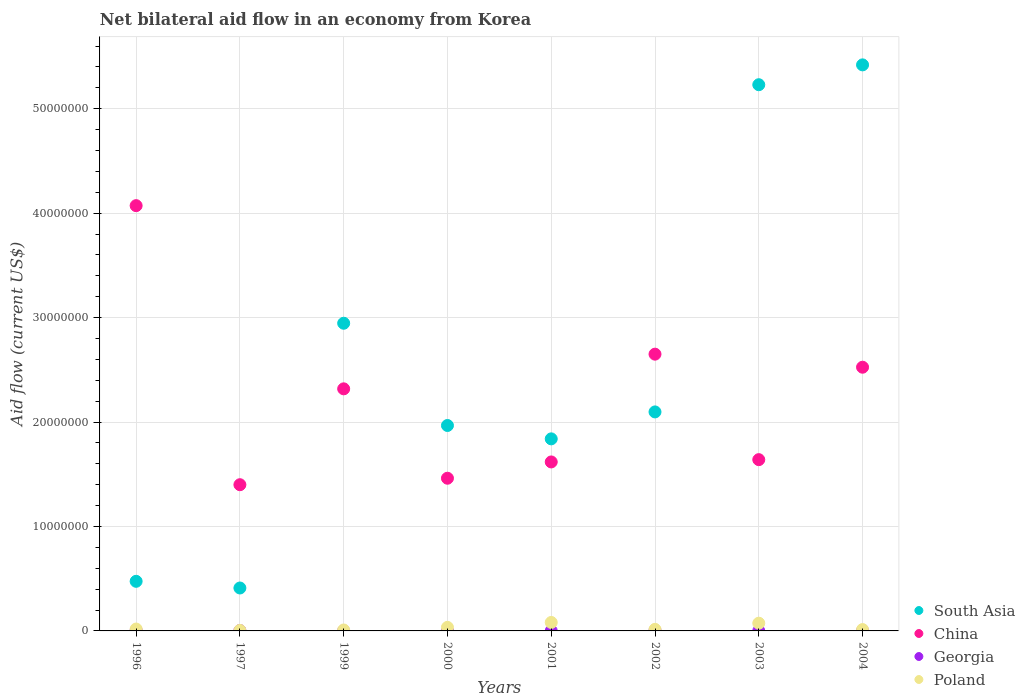Is the number of dotlines equal to the number of legend labels?
Provide a succinct answer. Yes. What is the net bilateral aid flow in China in 2004?
Your answer should be compact. 2.52e+07. Across all years, what is the maximum net bilateral aid flow in Poland?
Your answer should be very brief. 8.10e+05. Across all years, what is the minimum net bilateral aid flow in Georgia?
Keep it short and to the point. 10000. What is the total net bilateral aid flow in Georgia in the graph?
Offer a terse response. 2.30e+05. What is the difference between the net bilateral aid flow in Poland in 1997 and that in 2003?
Give a very brief answer. -6.90e+05. What is the difference between the net bilateral aid flow in Poland in 1999 and the net bilateral aid flow in South Asia in 1996?
Provide a short and direct response. -4.66e+06. What is the average net bilateral aid flow in South Asia per year?
Keep it short and to the point. 2.55e+07. In how many years, is the net bilateral aid flow in Georgia greater than 6000000 US$?
Your answer should be compact. 0. What is the ratio of the net bilateral aid flow in South Asia in 2001 to that in 2004?
Your answer should be very brief. 0.34. What is the difference between the highest and the lowest net bilateral aid flow in Poland?
Your answer should be compact. 7.60e+05. Is the sum of the net bilateral aid flow in Georgia in 1997 and 2004 greater than the maximum net bilateral aid flow in China across all years?
Keep it short and to the point. No. Is it the case that in every year, the sum of the net bilateral aid flow in Poland and net bilateral aid flow in China  is greater than the sum of net bilateral aid flow in Georgia and net bilateral aid flow in South Asia?
Your response must be concise. Yes. Is it the case that in every year, the sum of the net bilateral aid flow in China and net bilateral aid flow in Georgia  is greater than the net bilateral aid flow in South Asia?
Ensure brevity in your answer.  No. Does the net bilateral aid flow in Georgia monotonically increase over the years?
Your answer should be compact. No. Is the net bilateral aid flow in Poland strictly greater than the net bilateral aid flow in Georgia over the years?
Make the answer very short. Yes. How many dotlines are there?
Offer a very short reply. 4. How many years are there in the graph?
Offer a very short reply. 8. Does the graph contain any zero values?
Provide a short and direct response. No. Does the graph contain grids?
Your response must be concise. Yes. Where does the legend appear in the graph?
Provide a succinct answer. Bottom right. What is the title of the graph?
Provide a succinct answer. Net bilateral aid flow in an economy from Korea. Does "Senegal" appear as one of the legend labels in the graph?
Provide a short and direct response. No. What is the Aid flow (current US$) of South Asia in 1996?
Offer a terse response. 4.75e+06. What is the Aid flow (current US$) of China in 1996?
Make the answer very short. 4.07e+07. What is the Aid flow (current US$) in Georgia in 1996?
Keep it short and to the point. 5.00e+04. What is the Aid flow (current US$) of Poland in 1996?
Offer a very short reply. 1.80e+05. What is the Aid flow (current US$) of South Asia in 1997?
Make the answer very short. 4.11e+06. What is the Aid flow (current US$) of China in 1997?
Keep it short and to the point. 1.40e+07. What is the Aid flow (current US$) of South Asia in 1999?
Your answer should be compact. 2.95e+07. What is the Aid flow (current US$) in China in 1999?
Keep it short and to the point. 2.32e+07. What is the Aid flow (current US$) of South Asia in 2000?
Your response must be concise. 1.97e+07. What is the Aid flow (current US$) in China in 2000?
Keep it short and to the point. 1.46e+07. What is the Aid flow (current US$) in Georgia in 2000?
Provide a short and direct response. 3.00e+04. What is the Aid flow (current US$) in South Asia in 2001?
Your answer should be very brief. 1.84e+07. What is the Aid flow (current US$) of China in 2001?
Your answer should be compact. 1.62e+07. What is the Aid flow (current US$) in Poland in 2001?
Give a very brief answer. 8.10e+05. What is the Aid flow (current US$) in South Asia in 2002?
Your answer should be very brief. 2.10e+07. What is the Aid flow (current US$) in China in 2002?
Make the answer very short. 2.65e+07. What is the Aid flow (current US$) of Georgia in 2002?
Make the answer very short. 4.00e+04. What is the Aid flow (current US$) of Poland in 2002?
Ensure brevity in your answer.  1.50e+05. What is the Aid flow (current US$) in South Asia in 2003?
Ensure brevity in your answer.  5.23e+07. What is the Aid flow (current US$) in China in 2003?
Provide a short and direct response. 1.64e+07. What is the Aid flow (current US$) in Georgia in 2003?
Make the answer very short. 10000. What is the Aid flow (current US$) in Poland in 2003?
Your response must be concise. 7.40e+05. What is the Aid flow (current US$) in South Asia in 2004?
Keep it short and to the point. 5.42e+07. What is the Aid flow (current US$) of China in 2004?
Provide a succinct answer. 2.52e+07. What is the Aid flow (current US$) of Poland in 2004?
Ensure brevity in your answer.  1.30e+05. Across all years, what is the maximum Aid flow (current US$) in South Asia?
Offer a very short reply. 5.42e+07. Across all years, what is the maximum Aid flow (current US$) of China?
Provide a short and direct response. 4.07e+07. Across all years, what is the maximum Aid flow (current US$) of Georgia?
Your answer should be compact. 5.00e+04. Across all years, what is the maximum Aid flow (current US$) of Poland?
Provide a short and direct response. 8.10e+05. Across all years, what is the minimum Aid flow (current US$) of South Asia?
Ensure brevity in your answer.  4.11e+06. Across all years, what is the minimum Aid flow (current US$) of China?
Ensure brevity in your answer.  1.40e+07. Across all years, what is the minimum Aid flow (current US$) of Georgia?
Make the answer very short. 10000. What is the total Aid flow (current US$) in South Asia in the graph?
Offer a very short reply. 2.04e+08. What is the total Aid flow (current US$) in China in the graph?
Give a very brief answer. 1.77e+08. What is the total Aid flow (current US$) in Georgia in the graph?
Offer a terse response. 2.30e+05. What is the total Aid flow (current US$) of Poland in the graph?
Offer a very short reply. 2.49e+06. What is the difference between the Aid flow (current US$) of South Asia in 1996 and that in 1997?
Keep it short and to the point. 6.40e+05. What is the difference between the Aid flow (current US$) in China in 1996 and that in 1997?
Your answer should be very brief. 2.67e+07. What is the difference between the Aid flow (current US$) of Georgia in 1996 and that in 1997?
Your response must be concise. 10000. What is the difference between the Aid flow (current US$) in Poland in 1996 and that in 1997?
Offer a terse response. 1.30e+05. What is the difference between the Aid flow (current US$) in South Asia in 1996 and that in 1999?
Make the answer very short. -2.47e+07. What is the difference between the Aid flow (current US$) of China in 1996 and that in 1999?
Make the answer very short. 1.75e+07. What is the difference between the Aid flow (current US$) in Georgia in 1996 and that in 1999?
Offer a terse response. 4.00e+04. What is the difference between the Aid flow (current US$) in Poland in 1996 and that in 1999?
Your answer should be compact. 9.00e+04. What is the difference between the Aid flow (current US$) of South Asia in 1996 and that in 2000?
Your answer should be very brief. -1.49e+07. What is the difference between the Aid flow (current US$) of China in 1996 and that in 2000?
Your answer should be very brief. 2.61e+07. What is the difference between the Aid flow (current US$) of Georgia in 1996 and that in 2000?
Your answer should be compact. 2.00e+04. What is the difference between the Aid flow (current US$) of South Asia in 1996 and that in 2001?
Give a very brief answer. -1.36e+07. What is the difference between the Aid flow (current US$) in China in 1996 and that in 2001?
Provide a short and direct response. 2.45e+07. What is the difference between the Aid flow (current US$) of Georgia in 1996 and that in 2001?
Offer a very short reply. 4.00e+04. What is the difference between the Aid flow (current US$) in Poland in 1996 and that in 2001?
Provide a short and direct response. -6.30e+05. What is the difference between the Aid flow (current US$) in South Asia in 1996 and that in 2002?
Give a very brief answer. -1.62e+07. What is the difference between the Aid flow (current US$) of China in 1996 and that in 2002?
Offer a very short reply. 1.42e+07. What is the difference between the Aid flow (current US$) in South Asia in 1996 and that in 2003?
Your response must be concise. -4.76e+07. What is the difference between the Aid flow (current US$) of China in 1996 and that in 2003?
Provide a short and direct response. 2.43e+07. What is the difference between the Aid flow (current US$) of Poland in 1996 and that in 2003?
Ensure brevity in your answer.  -5.60e+05. What is the difference between the Aid flow (current US$) of South Asia in 1996 and that in 2004?
Your answer should be compact. -4.94e+07. What is the difference between the Aid flow (current US$) of China in 1996 and that in 2004?
Your answer should be compact. 1.55e+07. What is the difference between the Aid flow (current US$) in Georgia in 1996 and that in 2004?
Give a very brief answer. 10000. What is the difference between the Aid flow (current US$) in Poland in 1996 and that in 2004?
Give a very brief answer. 5.00e+04. What is the difference between the Aid flow (current US$) in South Asia in 1997 and that in 1999?
Provide a succinct answer. -2.54e+07. What is the difference between the Aid flow (current US$) in China in 1997 and that in 1999?
Ensure brevity in your answer.  -9.18e+06. What is the difference between the Aid flow (current US$) in Georgia in 1997 and that in 1999?
Make the answer very short. 3.00e+04. What is the difference between the Aid flow (current US$) of Poland in 1997 and that in 1999?
Give a very brief answer. -4.00e+04. What is the difference between the Aid flow (current US$) of South Asia in 1997 and that in 2000?
Offer a very short reply. -1.56e+07. What is the difference between the Aid flow (current US$) in China in 1997 and that in 2000?
Keep it short and to the point. -6.20e+05. What is the difference between the Aid flow (current US$) of South Asia in 1997 and that in 2001?
Make the answer very short. -1.43e+07. What is the difference between the Aid flow (current US$) in China in 1997 and that in 2001?
Offer a terse response. -2.18e+06. What is the difference between the Aid flow (current US$) in Georgia in 1997 and that in 2001?
Keep it short and to the point. 3.00e+04. What is the difference between the Aid flow (current US$) of Poland in 1997 and that in 2001?
Offer a very short reply. -7.60e+05. What is the difference between the Aid flow (current US$) in South Asia in 1997 and that in 2002?
Ensure brevity in your answer.  -1.69e+07. What is the difference between the Aid flow (current US$) in China in 1997 and that in 2002?
Offer a very short reply. -1.25e+07. What is the difference between the Aid flow (current US$) of Georgia in 1997 and that in 2002?
Give a very brief answer. 0. What is the difference between the Aid flow (current US$) of South Asia in 1997 and that in 2003?
Ensure brevity in your answer.  -4.82e+07. What is the difference between the Aid flow (current US$) in China in 1997 and that in 2003?
Keep it short and to the point. -2.40e+06. What is the difference between the Aid flow (current US$) of Georgia in 1997 and that in 2003?
Your answer should be very brief. 3.00e+04. What is the difference between the Aid flow (current US$) in Poland in 1997 and that in 2003?
Your answer should be compact. -6.90e+05. What is the difference between the Aid flow (current US$) in South Asia in 1997 and that in 2004?
Keep it short and to the point. -5.01e+07. What is the difference between the Aid flow (current US$) of China in 1997 and that in 2004?
Ensure brevity in your answer.  -1.12e+07. What is the difference between the Aid flow (current US$) of Poland in 1997 and that in 2004?
Provide a short and direct response. -8.00e+04. What is the difference between the Aid flow (current US$) of South Asia in 1999 and that in 2000?
Offer a very short reply. 9.79e+06. What is the difference between the Aid flow (current US$) of China in 1999 and that in 2000?
Your response must be concise. 8.56e+06. What is the difference between the Aid flow (current US$) of South Asia in 1999 and that in 2001?
Give a very brief answer. 1.11e+07. What is the difference between the Aid flow (current US$) of Georgia in 1999 and that in 2001?
Make the answer very short. 0. What is the difference between the Aid flow (current US$) in Poland in 1999 and that in 2001?
Your answer should be compact. -7.20e+05. What is the difference between the Aid flow (current US$) in South Asia in 1999 and that in 2002?
Keep it short and to the point. 8.49e+06. What is the difference between the Aid flow (current US$) in China in 1999 and that in 2002?
Ensure brevity in your answer.  -3.32e+06. What is the difference between the Aid flow (current US$) of Georgia in 1999 and that in 2002?
Provide a succinct answer. -3.00e+04. What is the difference between the Aid flow (current US$) in Poland in 1999 and that in 2002?
Give a very brief answer. -6.00e+04. What is the difference between the Aid flow (current US$) of South Asia in 1999 and that in 2003?
Your response must be concise. -2.28e+07. What is the difference between the Aid flow (current US$) of China in 1999 and that in 2003?
Offer a very short reply. 6.78e+06. What is the difference between the Aid flow (current US$) of Georgia in 1999 and that in 2003?
Ensure brevity in your answer.  0. What is the difference between the Aid flow (current US$) in Poland in 1999 and that in 2003?
Keep it short and to the point. -6.50e+05. What is the difference between the Aid flow (current US$) in South Asia in 1999 and that in 2004?
Your answer should be compact. -2.47e+07. What is the difference between the Aid flow (current US$) of China in 1999 and that in 2004?
Make the answer very short. -2.07e+06. What is the difference between the Aid flow (current US$) of Poland in 1999 and that in 2004?
Your response must be concise. -4.00e+04. What is the difference between the Aid flow (current US$) in South Asia in 2000 and that in 2001?
Your answer should be compact. 1.28e+06. What is the difference between the Aid flow (current US$) of China in 2000 and that in 2001?
Your answer should be very brief. -1.56e+06. What is the difference between the Aid flow (current US$) of Poland in 2000 and that in 2001?
Make the answer very short. -4.70e+05. What is the difference between the Aid flow (current US$) of South Asia in 2000 and that in 2002?
Provide a succinct answer. -1.30e+06. What is the difference between the Aid flow (current US$) of China in 2000 and that in 2002?
Make the answer very short. -1.19e+07. What is the difference between the Aid flow (current US$) of Georgia in 2000 and that in 2002?
Keep it short and to the point. -10000. What is the difference between the Aid flow (current US$) in Poland in 2000 and that in 2002?
Offer a very short reply. 1.90e+05. What is the difference between the Aid flow (current US$) of South Asia in 2000 and that in 2003?
Your answer should be compact. -3.26e+07. What is the difference between the Aid flow (current US$) in China in 2000 and that in 2003?
Your response must be concise. -1.78e+06. What is the difference between the Aid flow (current US$) in Georgia in 2000 and that in 2003?
Keep it short and to the point. 2.00e+04. What is the difference between the Aid flow (current US$) in Poland in 2000 and that in 2003?
Your answer should be compact. -4.00e+05. What is the difference between the Aid flow (current US$) of South Asia in 2000 and that in 2004?
Ensure brevity in your answer.  -3.45e+07. What is the difference between the Aid flow (current US$) of China in 2000 and that in 2004?
Your response must be concise. -1.06e+07. What is the difference between the Aid flow (current US$) of South Asia in 2001 and that in 2002?
Provide a succinct answer. -2.58e+06. What is the difference between the Aid flow (current US$) in China in 2001 and that in 2002?
Your answer should be compact. -1.03e+07. What is the difference between the Aid flow (current US$) of Georgia in 2001 and that in 2002?
Offer a terse response. -3.00e+04. What is the difference between the Aid flow (current US$) in Poland in 2001 and that in 2002?
Offer a terse response. 6.60e+05. What is the difference between the Aid flow (current US$) of South Asia in 2001 and that in 2003?
Offer a very short reply. -3.39e+07. What is the difference between the Aid flow (current US$) in Georgia in 2001 and that in 2003?
Your response must be concise. 0. What is the difference between the Aid flow (current US$) of South Asia in 2001 and that in 2004?
Your answer should be very brief. -3.58e+07. What is the difference between the Aid flow (current US$) in China in 2001 and that in 2004?
Provide a short and direct response. -9.07e+06. What is the difference between the Aid flow (current US$) in Poland in 2001 and that in 2004?
Your answer should be compact. 6.80e+05. What is the difference between the Aid flow (current US$) in South Asia in 2002 and that in 2003?
Offer a terse response. -3.13e+07. What is the difference between the Aid flow (current US$) in China in 2002 and that in 2003?
Provide a short and direct response. 1.01e+07. What is the difference between the Aid flow (current US$) in Georgia in 2002 and that in 2003?
Offer a terse response. 3.00e+04. What is the difference between the Aid flow (current US$) of Poland in 2002 and that in 2003?
Give a very brief answer. -5.90e+05. What is the difference between the Aid flow (current US$) of South Asia in 2002 and that in 2004?
Ensure brevity in your answer.  -3.32e+07. What is the difference between the Aid flow (current US$) in China in 2002 and that in 2004?
Ensure brevity in your answer.  1.25e+06. What is the difference between the Aid flow (current US$) in Georgia in 2002 and that in 2004?
Provide a succinct answer. 0. What is the difference between the Aid flow (current US$) of Poland in 2002 and that in 2004?
Offer a terse response. 2.00e+04. What is the difference between the Aid flow (current US$) in South Asia in 2003 and that in 2004?
Give a very brief answer. -1.90e+06. What is the difference between the Aid flow (current US$) in China in 2003 and that in 2004?
Offer a terse response. -8.85e+06. What is the difference between the Aid flow (current US$) in Poland in 2003 and that in 2004?
Give a very brief answer. 6.10e+05. What is the difference between the Aid flow (current US$) of South Asia in 1996 and the Aid flow (current US$) of China in 1997?
Provide a succinct answer. -9.25e+06. What is the difference between the Aid flow (current US$) of South Asia in 1996 and the Aid flow (current US$) of Georgia in 1997?
Keep it short and to the point. 4.71e+06. What is the difference between the Aid flow (current US$) in South Asia in 1996 and the Aid flow (current US$) in Poland in 1997?
Ensure brevity in your answer.  4.70e+06. What is the difference between the Aid flow (current US$) in China in 1996 and the Aid flow (current US$) in Georgia in 1997?
Keep it short and to the point. 4.07e+07. What is the difference between the Aid flow (current US$) of China in 1996 and the Aid flow (current US$) of Poland in 1997?
Ensure brevity in your answer.  4.07e+07. What is the difference between the Aid flow (current US$) in Georgia in 1996 and the Aid flow (current US$) in Poland in 1997?
Your response must be concise. 0. What is the difference between the Aid flow (current US$) of South Asia in 1996 and the Aid flow (current US$) of China in 1999?
Your response must be concise. -1.84e+07. What is the difference between the Aid flow (current US$) of South Asia in 1996 and the Aid flow (current US$) of Georgia in 1999?
Your answer should be compact. 4.74e+06. What is the difference between the Aid flow (current US$) in South Asia in 1996 and the Aid flow (current US$) in Poland in 1999?
Provide a succinct answer. 4.66e+06. What is the difference between the Aid flow (current US$) of China in 1996 and the Aid flow (current US$) of Georgia in 1999?
Ensure brevity in your answer.  4.07e+07. What is the difference between the Aid flow (current US$) of China in 1996 and the Aid flow (current US$) of Poland in 1999?
Give a very brief answer. 4.06e+07. What is the difference between the Aid flow (current US$) of Georgia in 1996 and the Aid flow (current US$) of Poland in 1999?
Your response must be concise. -4.00e+04. What is the difference between the Aid flow (current US$) of South Asia in 1996 and the Aid flow (current US$) of China in 2000?
Make the answer very short. -9.87e+06. What is the difference between the Aid flow (current US$) in South Asia in 1996 and the Aid flow (current US$) in Georgia in 2000?
Make the answer very short. 4.72e+06. What is the difference between the Aid flow (current US$) in South Asia in 1996 and the Aid flow (current US$) in Poland in 2000?
Make the answer very short. 4.41e+06. What is the difference between the Aid flow (current US$) of China in 1996 and the Aid flow (current US$) of Georgia in 2000?
Give a very brief answer. 4.07e+07. What is the difference between the Aid flow (current US$) in China in 1996 and the Aid flow (current US$) in Poland in 2000?
Offer a terse response. 4.04e+07. What is the difference between the Aid flow (current US$) of Georgia in 1996 and the Aid flow (current US$) of Poland in 2000?
Your response must be concise. -2.90e+05. What is the difference between the Aid flow (current US$) in South Asia in 1996 and the Aid flow (current US$) in China in 2001?
Offer a very short reply. -1.14e+07. What is the difference between the Aid flow (current US$) of South Asia in 1996 and the Aid flow (current US$) of Georgia in 2001?
Give a very brief answer. 4.74e+06. What is the difference between the Aid flow (current US$) in South Asia in 1996 and the Aid flow (current US$) in Poland in 2001?
Your answer should be compact. 3.94e+06. What is the difference between the Aid flow (current US$) in China in 1996 and the Aid flow (current US$) in Georgia in 2001?
Ensure brevity in your answer.  4.07e+07. What is the difference between the Aid flow (current US$) in China in 1996 and the Aid flow (current US$) in Poland in 2001?
Provide a succinct answer. 3.99e+07. What is the difference between the Aid flow (current US$) of Georgia in 1996 and the Aid flow (current US$) of Poland in 2001?
Provide a short and direct response. -7.60e+05. What is the difference between the Aid flow (current US$) in South Asia in 1996 and the Aid flow (current US$) in China in 2002?
Offer a very short reply. -2.18e+07. What is the difference between the Aid flow (current US$) in South Asia in 1996 and the Aid flow (current US$) in Georgia in 2002?
Keep it short and to the point. 4.71e+06. What is the difference between the Aid flow (current US$) in South Asia in 1996 and the Aid flow (current US$) in Poland in 2002?
Make the answer very short. 4.60e+06. What is the difference between the Aid flow (current US$) in China in 1996 and the Aid flow (current US$) in Georgia in 2002?
Your answer should be very brief. 4.07e+07. What is the difference between the Aid flow (current US$) in China in 1996 and the Aid flow (current US$) in Poland in 2002?
Provide a succinct answer. 4.06e+07. What is the difference between the Aid flow (current US$) of South Asia in 1996 and the Aid flow (current US$) of China in 2003?
Your response must be concise. -1.16e+07. What is the difference between the Aid flow (current US$) of South Asia in 1996 and the Aid flow (current US$) of Georgia in 2003?
Your answer should be compact. 4.74e+06. What is the difference between the Aid flow (current US$) of South Asia in 1996 and the Aid flow (current US$) of Poland in 2003?
Offer a terse response. 4.01e+06. What is the difference between the Aid flow (current US$) of China in 1996 and the Aid flow (current US$) of Georgia in 2003?
Make the answer very short. 4.07e+07. What is the difference between the Aid flow (current US$) of China in 1996 and the Aid flow (current US$) of Poland in 2003?
Offer a very short reply. 4.00e+07. What is the difference between the Aid flow (current US$) of Georgia in 1996 and the Aid flow (current US$) of Poland in 2003?
Ensure brevity in your answer.  -6.90e+05. What is the difference between the Aid flow (current US$) in South Asia in 1996 and the Aid flow (current US$) in China in 2004?
Give a very brief answer. -2.05e+07. What is the difference between the Aid flow (current US$) of South Asia in 1996 and the Aid flow (current US$) of Georgia in 2004?
Your response must be concise. 4.71e+06. What is the difference between the Aid flow (current US$) in South Asia in 1996 and the Aid flow (current US$) in Poland in 2004?
Your answer should be compact. 4.62e+06. What is the difference between the Aid flow (current US$) in China in 1996 and the Aid flow (current US$) in Georgia in 2004?
Your response must be concise. 4.07e+07. What is the difference between the Aid flow (current US$) of China in 1996 and the Aid flow (current US$) of Poland in 2004?
Keep it short and to the point. 4.06e+07. What is the difference between the Aid flow (current US$) of South Asia in 1997 and the Aid flow (current US$) of China in 1999?
Give a very brief answer. -1.91e+07. What is the difference between the Aid flow (current US$) in South Asia in 1997 and the Aid flow (current US$) in Georgia in 1999?
Make the answer very short. 4.10e+06. What is the difference between the Aid flow (current US$) in South Asia in 1997 and the Aid flow (current US$) in Poland in 1999?
Your answer should be compact. 4.02e+06. What is the difference between the Aid flow (current US$) in China in 1997 and the Aid flow (current US$) in Georgia in 1999?
Keep it short and to the point. 1.40e+07. What is the difference between the Aid flow (current US$) in China in 1997 and the Aid flow (current US$) in Poland in 1999?
Give a very brief answer. 1.39e+07. What is the difference between the Aid flow (current US$) in Georgia in 1997 and the Aid flow (current US$) in Poland in 1999?
Provide a short and direct response. -5.00e+04. What is the difference between the Aid flow (current US$) of South Asia in 1997 and the Aid flow (current US$) of China in 2000?
Your response must be concise. -1.05e+07. What is the difference between the Aid flow (current US$) in South Asia in 1997 and the Aid flow (current US$) in Georgia in 2000?
Your answer should be very brief. 4.08e+06. What is the difference between the Aid flow (current US$) in South Asia in 1997 and the Aid flow (current US$) in Poland in 2000?
Make the answer very short. 3.77e+06. What is the difference between the Aid flow (current US$) in China in 1997 and the Aid flow (current US$) in Georgia in 2000?
Give a very brief answer. 1.40e+07. What is the difference between the Aid flow (current US$) of China in 1997 and the Aid flow (current US$) of Poland in 2000?
Ensure brevity in your answer.  1.37e+07. What is the difference between the Aid flow (current US$) in South Asia in 1997 and the Aid flow (current US$) in China in 2001?
Your response must be concise. -1.21e+07. What is the difference between the Aid flow (current US$) in South Asia in 1997 and the Aid flow (current US$) in Georgia in 2001?
Your answer should be very brief. 4.10e+06. What is the difference between the Aid flow (current US$) in South Asia in 1997 and the Aid flow (current US$) in Poland in 2001?
Your answer should be very brief. 3.30e+06. What is the difference between the Aid flow (current US$) of China in 1997 and the Aid flow (current US$) of Georgia in 2001?
Make the answer very short. 1.40e+07. What is the difference between the Aid flow (current US$) in China in 1997 and the Aid flow (current US$) in Poland in 2001?
Ensure brevity in your answer.  1.32e+07. What is the difference between the Aid flow (current US$) of Georgia in 1997 and the Aid flow (current US$) of Poland in 2001?
Ensure brevity in your answer.  -7.70e+05. What is the difference between the Aid flow (current US$) of South Asia in 1997 and the Aid flow (current US$) of China in 2002?
Your response must be concise. -2.24e+07. What is the difference between the Aid flow (current US$) in South Asia in 1997 and the Aid flow (current US$) in Georgia in 2002?
Your answer should be compact. 4.07e+06. What is the difference between the Aid flow (current US$) in South Asia in 1997 and the Aid flow (current US$) in Poland in 2002?
Your answer should be very brief. 3.96e+06. What is the difference between the Aid flow (current US$) in China in 1997 and the Aid flow (current US$) in Georgia in 2002?
Your answer should be very brief. 1.40e+07. What is the difference between the Aid flow (current US$) of China in 1997 and the Aid flow (current US$) of Poland in 2002?
Keep it short and to the point. 1.38e+07. What is the difference between the Aid flow (current US$) in South Asia in 1997 and the Aid flow (current US$) in China in 2003?
Keep it short and to the point. -1.23e+07. What is the difference between the Aid flow (current US$) in South Asia in 1997 and the Aid flow (current US$) in Georgia in 2003?
Give a very brief answer. 4.10e+06. What is the difference between the Aid flow (current US$) of South Asia in 1997 and the Aid flow (current US$) of Poland in 2003?
Provide a succinct answer. 3.37e+06. What is the difference between the Aid flow (current US$) in China in 1997 and the Aid flow (current US$) in Georgia in 2003?
Offer a very short reply. 1.40e+07. What is the difference between the Aid flow (current US$) of China in 1997 and the Aid flow (current US$) of Poland in 2003?
Make the answer very short. 1.33e+07. What is the difference between the Aid flow (current US$) in Georgia in 1997 and the Aid flow (current US$) in Poland in 2003?
Make the answer very short. -7.00e+05. What is the difference between the Aid flow (current US$) in South Asia in 1997 and the Aid flow (current US$) in China in 2004?
Keep it short and to the point. -2.11e+07. What is the difference between the Aid flow (current US$) in South Asia in 1997 and the Aid flow (current US$) in Georgia in 2004?
Keep it short and to the point. 4.07e+06. What is the difference between the Aid flow (current US$) in South Asia in 1997 and the Aid flow (current US$) in Poland in 2004?
Provide a succinct answer. 3.98e+06. What is the difference between the Aid flow (current US$) in China in 1997 and the Aid flow (current US$) in Georgia in 2004?
Your answer should be very brief. 1.40e+07. What is the difference between the Aid flow (current US$) in China in 1997 and the Aid flow (current US$) in Poland in 2004?
Provide a succinct answer. 1.39e+07. What is the difference between the Aid flow (current US$) of Georgia in 1997 and the Aid flow (current US$) of Poland in 2004?
Offer a very short reply. -9.00e+04. What is the difference between the Aid flow (current US$) of South Asia in 1999 and the Aid flow (current US$) of China in 2000?
Make the answer very short. 1.48e+07. What is the difference between the Aid flow (current US$) of South Asia in 1999 and the Aid flow (current US$) of Georgia in 2000?
Your answer should be very brief. 2.94e+07. What is the difference between the Aid flow (current US$) in South Asia in 1999 and the Aid flow (current US$) in Poland in 2000?
Your answer should be very brief. 2.91e+07. What is the difference between the Aid flow (current US$) of China in 1999 and the Aid flow (current US$) of Georgia in 2000?
Ensure brevity in your answer.  2.32e+07. What is the difference between the Aid flow (current US$) of China in 1999 and the Aid flow (current US$) of Poland in 2000?
Your answer should be very brief. 2.28e+07. What is the difference between the Aid flow (current US$) in Georgia in 1999 and the Aid flow (current US$) in Poland in 2000?
Offer a terse response. -3.30e+05. What is the difference between the Aid flow (current US$) of South Asia in 1999 and the Aid flow (current US$) of China in 2001?
Your response must be concise. 1.33e+07. What is the difference between the Aid flow (current US$) of South Asia in 1999 and the Aid flow (current US$) of Georgia in 2001?
Your answer should be very brief. 2.94e+07. What is the difference between the Aid flow (current US$) of South Asia in 1999 and the Aid flow (current US$) of Poland in 2001?
Offer a very short reply. 2.86e+07. What is the difference between the Aid flow (current US$) in China in 1999 and the Aid flow (current US$) in Georgia in 2001?
Provide a short and direct response. 2.32e+07. What is the difference between the Aid flow (current US$) of China in 1999 and the Aid flow (current US$) of Poland in 2001?
Ensure brevity in your answer.  2.24e+07. What is the difference between the Aid flow (current US$) in Georgia in 1999 and the Aid flow (current US$) in Poland in 2001?
Ensure brevity in your answer.  -8.00e+05. What is the difference between the Aid flow (current US$) of South Asia in 1999 and the Aid flow (current US$) of China in 2002?
Offer a terse response. 2.96e+06. What is the difference between the Aid flow (current US$) of South Asia in 1999 and the Aid flow (current US$) of Georgia in 2002?
Your answer should be very brief. 2.94e+07. What is the difference between the Aid flow (current US$) in South Asia in 1999 and the Aid flow (current US$) in Poland in 2002?
Make the answer very short. 2.93e+07. What is the difference between the Aid flow (current US$) of China in 1999 and the Aid flow (current US$) of Georgia in 2002?
Offer a terse response. 2.31e+07. What is the difference between the Aid flow (current US$) in China in 1999 and the Aid flow (current US$) in Poland in 2002?
Offer a very short reply. 2.30e+07. What is the difference between the Aid flow (current US$) in South Asia in 1999 and the Aid flow (current US$) in China in 2003?
Make the answer very short. 1.31e+07. What is the difference between the Aid flow (current US$) in South Asia in 1999 and the Aid flow (current US$) in Georgia in 2003?
Your answer should be compact. 2.94e+07. What is the difference between the Aid flow (current US$) in South Asia in 1999 and the Aid flow (current US$) in Poland in 2003?
Provide a succinct answer. 2.87e+07. What is the difference between the Aid flow (current US$) of China in 1999 and the Aid flow (current US$) of Georgia in 2003?
Your answer should be compact. 2.32e+07. What is the difference between the Aid flow (current US$) in China in 1999 and the Aid flow (current US$) in Poland in 2003?
Your answer should be compact. 2.24e+07. What is the difference between the Aid flow (current US$) in Georgia in 1999 and the Aid flow (current US$) in Poland in 2003?
Keep it short and to the point. -7.30e+05. What is the difference between the Aid flow (current US$) of South Asia in 1999 and the Aid flow (current US$) of China in 2004?
Make the answer very short. 4.21e+06. What is the difference between the Aid flow (current US$) in South Asia in 1999 and the Aid flow (current US$) in Georgia in 2004?
Provide a short and direct response. 2.94e+07. What is the difference between the Aid flow (current US$) in South Asia in 1999 and the Aid flow (current US$) in Poland in 2004?
Ensure brevity in your answer.  2.93e+07. What is the difference between the Aid flow (current US$) in China in 1999 and the Aid flow (current US$) in Georgia in 2004?
Ensure brevity in your answer.  2.31e+07. What is the difference between the Aid flow (current US$) of China in 1999 and the Aid flow (current US$) of Poland in 2004?
Provide a short and direct response. 2.30e+07. What is the difference between the Aid flow (current US$) in South Asia in 2000 and the Aid flow (current US$) in China in 2001?
Your answer should be compact. 3.49e+06. What is the difference between the Aid flow (current US$) of South Asia in 2000 and the Aid flow (current US$) of Georgia in 2001?
Offer a very short reply. 1.97e+07. What is the difference between the Aid flow (current US$) of South Asia in 2000 and the Aid flow (current US$) of Poland in 2001?
Offer a very short reply. 1.89e+07. What is the difference between the Aid flow (current US$) in China in 2000 and the Aid flow (current US$) in Georgia in 2001?
Give a very brief answer. 1.46e+07. What is the difference between the Aid flow (current US$) of China in 2000 and the Aid flow (current US$) of Poland in 2001?
Your answer should be very brief. 1.38e+07. What is the difference between the Aid flow (current US$) in Georgia in 2000 and the Aid flow (current US$) in Poland in 2001?
Offer a terse response. -7.80e+05. What is the difference between the Aid flow (current US$) in South Asia in 2000 and the Aid flow (current US$) in China in 2002?
Keep it short and to the point. -6.83e+06. What is the difference between the Aid flow (current US$) of South Asia in 2000 and the Aid flow (current US$) of Georgia in 2002?
Make the answer very short. 1.96e+07. What is the difference between the Aid flow (current US$) of South Asia in 2000 and the Aid flow (current US$) of Poland in 2002?
Give a very brief answer. 1.95e+07. What is the difference between the Aid flow (current US$) of China in 2000 and the Aid flow (current US$) of Georgia in 2002?
Provide a short and direct response. 1.46e+07. What is the difference between the Aid flow (current US$) in China in 2000 and the Aid flow (current US$) in Poland in 2002?
Your response must be concise. 1.45e+07. What is the difference between the Aid flow (current US$) of Georgia in 2000 and the Aid flow (current US$) of Poland in 2002?
Keep it short and to the point. -1.20e+05. What is the difference between the Aid flow (current US$) in South Asia in 2000 and the Aid flow (current US$) in China in 2003?
Provide a short and direct response. 3.27e+06. What is the difference between the Aid flow (current US$) of South Asia in 2000 and the Aid flow (current US$) of Georgia in 2003?
Make the answer very short. 1.97e+07. What is the difference between the Aid flow (current US$) of South Asia in 2000 and the Aid flow (current US$) of Poland in 2003?
Offer a terse response. 1.89e+07. What is the difference between the Aid flow (current US$) of China in 2000 and the Aid flow (current US$) of Georgia in 2003?
Keep it short and to the point. 1.46e+07. What is the difference between the Aid flow (current US$) in China in 2000 and the Aid flow (current US$) in Poland in 2003?
Your answer should be compact. 1.39e+07. What is the difference between the Aid flow (current US$) in Georgia in 2000 and the Aid flow (current US$) in Poland in 2003?
Your response must be concise. -7.10e+05. What is the difference between the Aid flow (current US$) of South Asia in 2000 and the Aid flow (current US$) of China in 2004?
Offer a very short reply. -5.58e+06. What is the difference between the Aid flow (current US$) of South Asia in 2000 and the Aid flow (current US$) of Georgia in 2004?
Your response must be concise. 1.96e+07. What is the difference between the Aid flow (current US$) of South Asia in 2000 and the Aid flow (current US$) of Poland in 2004?
Offer a terse response. 1.95e+07. What is the difference between the Aid flow (current US$) of China in 2000 and the Aid flow (current US$) of Georgia in 2004?
Give a very brief answer. 1.46e+07. What is the difference between the Aid flow (current US$) of China in 2000 and the Aid flow (current US$) of Poland in 2004?
Provide a short and direct response. 1.45e+07. What is the difference between the Aid flow (current US$) of South Asia in 2001 and the Aid flow (current US$) of China in 2002?
Give a very brief answer. -8.11e+06. What is the difference between the Aid flow (current US$) of South Asia in 2001 and the Aid flow (current US$) of Georgia in 2002?
Ensure brevity in your answer.  1.84e+07. What is the difference between the Aid flow (current US$) of South Asia in 2001 and the Aid flow (current US$) of Poland in 2002?
Ensure brevity in your answer.  1.82e+07. What is the difference between the Aid flow (current US$) of China in 2001 and the Aid flow (current US$) of Georgia in 2002?
Your answer should be very brief. 1.61e+07. What is the difference between the Aid flow (current US$) in China in 2001 and the Aid flow (current US$) in Poland in 2002?
Provide a succinct answer. 1.60e+07. What is the difference between the Aid flow (current US$) in Georgia in 2001 and the Aid flow (current US$) in Poland in 2002?
Your answer should be compact. -1.40e+05. What is the difference between the Aid flow (current US$) of South Asia in 2001 and the Aid flow (current US$) of China in 2003?
Ensure brevity in your answer.  1.99e+06. What is the difference between the Aid flow (current US$) in South Asia in 2001 and the Aid flow (current US$) in Georgia in 2003?
Your response must be concise. 1.84e+07. What is the difference between the Aid flow (current US$) of South Asia in 2001 and the Aid flow (current US$) of Poland in 2003?
Your answer should be very brief. 1.76e+07. What is the difference between the Aid flow (current US$) of China in 2001 and the Aid flow (current US$) of Georgia in 2003?
Ensure brevity in your answer.  1.62e+07. What is the difference between the Aid flow (current US$) of China in 2001 and the Aid flow (current US$) of Poland in 2003?
Keep it short and to the point. 1.54e+07. What is the difference between the Aid flow (current US$) of Georgia in 2001 and the Aid flow (current US$) of Poland in 2003?
Make the answer very short. -7.30e+05. What is the difference between the Aid flow (current US$) in South Asia in 2001 and the Aid flow (current US$) in China in 2004?
Make the answer very short. -6.86e+06. What is the difference between the Aid flow (current US$) in South Asia in 2001 and the Aid flow (current US$) in Georgia in 2004?
Give a very brief answer. 1.84e+07. What is the difference between the Aid flow (current US$) in South Asia in 2001 and the Aid flow (current US$) in Poland in 2004?
Keep it short and to the point. 1.83e+07. What is the difference between the Aid flow (current US$) in China in 2001 and the Aid flow (current US$) in Georgia in 2004?
Offer a terse response. 1.61e+07. What is the difference between the Aid flow (current US$) in China in 2001 and the Aid flow (current US$) in Poland in 2004?
Ensure brevity in your answer.  1.60e+07. What is the difference between the Aid flow (current US$) of South Asia in 2002 and the Aid flow (current US$) of China in 2003?
Provide a succinct answer. 4.57e+06. What is the difference between the Aid flow (current US$) of South Asia in 2002 and the Aid flow (current US$) of Georgia in 2003?
Offer a terse response. 2.10e+07. What is the difference between the Aid flow (current US$) of South Asia in 2002 and the Aid flow (current US$) of Poland in 2003?
Offer a very short reply. 2.02e+07. What is the difference between the Aid flow (current US$) in China in 2002 and the Aid flow (current US$) in Georgia in 2003?
Provide a succinct answer. 2.65e+07. What is the difference between the Aid flow (current US$) of China in 2002 and the Aid flow (current US$) of Poland in 2003?
Provide a succinct answer. 2.58e+07. What is the difference between the Aid flow (current US$) of Georgia in 2002 and the Aid flow (current US$) of Poland in 2003?
Ensure brevity in your answer.  -7.00e+05. What is the difference between the Aid flow (current US$) in South Asia in 2002 and the Aid flow (current US$) in China in 2004?
Provide a short and direct response. -4.28e+06. What is the difference between the Aid flow (current US$) in South Asia in 2002 and the Aid flow (current US$) in Georgia in 2004?
Your answer should be compact. 2.09e+07. What is the difference between the Aid flow (current US$) of South Asia in 2002 and the Aid flow (current US$) of Poland in 2004?
Keep it short and to the point. 2.08e+07. What is the difference between the Aid flow (current US$) in China in 2002 and the Aid flow (current US$) in Georgia in 2004?
Make the answer very short. 2.65e+07. What is the difference between the Aid flow (current US$) of China in 2002 and the Aid flow (current US$) of Poland in 2004?
Provide a succinct answer. 2.64e+07. What is the difference between the Aid flow (current US$) in Georgia in 2002 and the Aid flow (current US$) in Poland in 2004?
Your answer should be compact. -9.00e+04. What is the difference between the Aid flow (current US$) in South Asia in 2003 and the Aid flow (current US$) in China in 2004?
Ensure brevity in your answer.  2.70e+07. What is the difference between the Aid flow (current US$) in South Asia in 2003 and the Aid flow (current US$) in Georgia in 2004?
Provide a short and direct response. 5.23e+07. What is the difference between the Aid flow (current US$) of South Asia in 2003 and the Aid flow (current US$) of Poland in 2004?
Your answer should be very brief. 5.22e+07. What is the difference between the Aid flow (current US$) of China in 2003 and the Aid flow (current US$) of Georgia in 2004?
Provide a succinct answer. 1.64e+07. What is the difference between the Aid flow (current US$) of China in 2003 and the Aid flow (current US$) of Poland in 2004?
Make the answer very short. 1.63e+07. What is the average Aid flow (current US$) of South Asia per year?
Your answer should be compact. 2.55e+07. What is the average Aid flow (current US$) of China per year?
Keep it short and to the point. 2.21e+07. What is the average Aid flow (current US$) of Georgia per year?
Your answer should be compact. 2.88e+04. What is the average Aid flow (current US$) in Poland per year?
Your answer should be very brief. 3.11e+05. In the year 1996, what is the difference between the Aid flow (current US$) of South Asia and Aid flow (current US$) of China?
Your answer should be very brief. -3.60e+07. In the year 1996, what is the difference between the Aid flow (current US$) in South Asia and Aid flow (current US$) in Georgia?
Ensure brevity in your answer.  4.70e+06. In the year 1996, what is the difference between the Aid flow (current US$) in South Asia and Aid flow (current US$) in Poland?
Ensure brevity in your answer.  4.57e+06. In the year 1996, what is the difference between the Aid flow (current US$) in China and Aid flow (current US$) in Georgia?
Offer a very short reply. 4.07e+07. In the year 1996, what is the difference between the Aid flow (current US$) in China and Aid flow (current US$) in Poland?
Your answer should be very brief. 4.05e+07. In the year 1997, what is the difference between the Aid flow (current US$) in South Asia and Aid flow (current US$) in China?
Your answer should be compact. -9.89e+06. In the year 1997, what is the difference between the Aid flow (current US$) of South Asia and Aid flow (current US$) of Georgia?
Offer a very short reply. 4.07e+06. In the year 1997, what is the difference between the Aid flow (current US$) in South Asia and Aid flow (current US$) in Poland?
Provide a succinct answer. 4.06e+06. In the year 1997, what is the difference between the Aid flow (current US$) of China and Aid flow (current US$) of Georgia?
Provide a succinct answer. 1.40e+07. In the year 1997, what is the difference between the Aid flow (current US$) in China and Aid flow (current US$) in Poland?
Offer a very short reply. 1.40e+07. In the year 1999, what is the difference between the Aid flow (current US$) of South Asia and Aid flow (current US$) of China?
Your answer should be compact. 6.28e+06. In the year 1999, what is the difference between the Aid flow (current US$) in South Asia and Aid flow (current US$) in Georgia?
Make the answer very short. 2.94e+07. In the year 1999, what is the difference between the Aid flow (current US$) in South Asia and Aid flow (current US$) in Poland?
Your answer should be very brief. 2.94e+07. In the year 1999, what is the difference between the Aid flow (current US$) in China and Aid flow (current US$) in Georgia?
Provide a succinct answer. 2.32e+07. In the year 1999, what is the difference between the Aid flow (current US$) of China and Aid flow (current US$) of Poland?
Your answer should be compact. 2.31e+07. In the year 2000, what is the difference between the Aid flow (current US$) in South Asia and Aid flow (current US$) in China?
Offer a terse response. 5.05e+06. In the year 2000, what is the difference between the Aid flow (current US$) of South Asia and Aid flow (current US$) of Georgia?
Offer a very short reply. 1.96e+07. In the year 2000, what is the difference between the Aid flow (current US$) in South Asia and Aid flow (current US$) in Poland?
Provide a succinct answer. 1.93e+07. In the year 2000, what is the difference between the Aid flow (current US$) of China and Aid flow (current US$) of Georgia?
Keep it short and to the point. 1.46e+07. In the year 2000, what is the difference between the Aid flow (current US$) in China and Aid flow (current US$) in Poland?
Keep it short and to the point. 1.43e+07. In the year 2000, what is the difference between the Aid flow (current US$) in Georgia and Aid flow (current US$) in Poland?
Ensure brevity in your answer.  -3.10e+05. In the year 2001, what is the difference between the Aid flow (current US$) in South Asia and Aid flow (current US$) in China?
Keep it short and to the point. 2.21e+06. In the year 2001, what is the difference between the Aid flow (current US$) in South Asia and Aid flow (current US$) in Georgia?
Offer a terse response. 1.84e+07. In the year 2001, what is the difference between the Aid flow (current US$) in South Asia and Aid flow (current US$) in Poland?
Provide a short and direct response. 1.76e+07. In the year 2001, what is the difference between the Aid flow (current US$) of China and Aid flow (current US$) of Georgia?
Provide a short and direct response. 1.62e+07. In the year 2001, what is the difference between the Aid flow (current US$) of China and Aid flow (current US$) of Poland?
Ensure brevity in your answer.  1.54e+07. In the year 2001, what is the difference between the Aid flow (current US$) of Georgia and Aid flow (current US$) of Poland?
Your answer should be very brief. -8.00e+05. In the year 2002, what is the difference between the Aid flow (current US$) in South Asia and Aid flow (current US$) in China?
Make the answer very short. -5.53e+06. In the year 2002, what is the difference between the Aid flow (current US$) in South Asia and Aid flow (current US$) in Georgia?
Offer a terse response. 2.09e+07. In the year 2002, what is the difference between the Aid flow (current US$) of South Asia and Aid flow (current US$) of Poland?
Your response must be concise. 2.08e+07. In the year 2002, what is the difference between the Aid flow (current US$) of China and Aid flow (current US$) of Georgia?
Offer a very short reply. 2.65e+07. In the year 2002, what is the difference between the Aid flow (current US$) in China and Aid flow (current US$) in Poland?
Provide a short and direct response. 2.64e+07. In the year 2003, what is the difference between the Aid flow (current US$) in South Asia and Aid flow (current US$) in China?
Your answer should be compact. 3.59e+07. In the year 2003, what is the difference between the Aid flow (current US$) of South Asia and Aid flow (current US$) of Georgia?
Provide a short and direct response. 5.23e+07. In the year 2003, what is the difference between the Aid flow (current US$) of South Asia and Aid flow (current US$) of Poland?
Your answer should be compact. 5.16e+07. In the year 2003, what is the difference between the Aid flow (current US$) of China and Aid flow (current US$) of Georgia?
Your answer should be very brief. 1.64e+07. In the year 2003, what is the difference between the Aid flow (current US$) in China and Aid flow (current US$) in Poland?
Provide a short and direct response. 1.57e+07. In the year 2003, what is the difference between the Aid flow (current US$) in Georgia and Aid flow (current US$) in Poland?
Offer a very short reply. -7.30e+05. In the year 2004, what is the difference between the Aid flow (current US$) of South Asia and Aid flow (current US$) of China?
Provide a succinct answer. 2.90e+07. In the year 2004, what is the difference between the Aid flow (current US$) in South Asia and Aid flow (current US$) in Georgia?
Offer a terse response. 5.42e+07. In the year 2004, what is the difference between the Aid flow (current US$) of South Asia and Aid flow (current US$) of Poland?
Ensure brevity in your answer.  5.41e+07. In the year 2004, what is the difference between the Aid flow (current US$) in China and Aid flow (current US$) in Georgia?
Keep it short and to the point. 2.52e+07. In the year 2004, what is the difference between the Aid flow (current US$) of China and Aid flow (current US$) of Poland?
Your response must be concise. 2.51e+07. In the year 2004, what is the difference between the Aid flow (current US$) of Georgia and Aid flow (current US$) of Poland?
Your answer should be compact. -9.00e+04. What is the ratio of the Aid flow (current US$) of South Asia in 1996 to that in 1997?
Your response must be concise. 1.16. What is the ratio of the Aid flow (current US$) of China in 1996 to that in 1997?
Make the answer very short. 2.91. What is the ratio of the Aid flow (current US$) in Poland in 1996 to that in 1997?
Make the answer very short. 3.6. What is the ratio of the Aid flow (current US$) of South Asia in 1996 to that in 1999?
Make the answer very short. 0.16. What is the ratio of the Aid flow (current US$) in China in 1996 to that in 1999?
Offer a very short reply. 1.76. What is the ratio of the Aid flow (current US$) of South Asia in 1996 to that in 2000?
Provide a short and direct response. 0.24. What is the ratio of the Aid flow (current US$) in China in 1996 to that in 2000?
Your answer should be compact. 2.79. What is the ratio of the Aid flow (current US$) in Georgia in 1996 to that in 2000?
Your response must be concise. 1.67. What is the ratio of the Aid flow (current US$) of Poland in 1996 to that in 2000?
Make the answer very short. 0.53. What is the ratio of the Aid flow (current US$) in South Asia in 1996 to that in 2001?
Provide a short and direct response. 0.26. What is the ratio of the Aid flow (current US$) of China in 1996 to that in 2001?
Your answer should be compact. 2.52. What is the ratio of the Aid flow (current US$) of Georgia in 1996 to that in 2001?
Your answer should be very brief. 5. What is the ratio of the Aid flow (current US$) in Poland in 1996 to that in 2001?
Provide a short and direct response. 0.22. What is the ratio of the Aid flow (current US$) in South Asia in 1996 to that in 2002?
Your response must be concise. 0.23. What is the ratio of the Aid flow (current US$) in China in 1996 to that in 2002?
Provide a succinct answer. 1.54. What is the ratio of the Aid flow (current US$) of Poland in 1996 to that in 2002?
Your response must be concise. 1.2. What is the ratio of the Aid flow (current US$) in South Asia in 1996 to that in 2003?
Offer a very short reply. 0.09. What is the ratio of the Aid flow (current US$) of China in 1996 to that in 2003?
Provide a short and direct response. 2.48. What is the ratio of the Aid flow (current US$) in Georgia in 1996 to that in 2003?
Ensure brevity in your answer.  5. What is the ratio of the Aid flow (current US$) of Poland in 1996 to that in 2003?
Provide a succinct answer. 0.24. What is the ratio of the Aid flow (current US$) in South Asia in 1996 to that in 2004?
Offer a very short reply. 0.09. What is the ratio of the Aid flow (current US$) of China in 1996 to that in 2004?
Give a very brief answer. 1.61. What is the ratio of the Aid flow (current US$) of Poland in 1996 to that in 2004?
Make the answer very short. 1.38. What is the ratio of the Aid flow (current US$) of South Asia in 1997 to that in 1999?
Your answer should be compact. 0.14. What is the ratio of the Aid flow (current US$) of China in 1997 to that in 1999?
Provide a short and direct response. 0.6. What is the ratio of the Aid flow (current US$) in Georgia in 1997 to that in 1999?
Give a very brief answer. 4. What is the ratio of the Aid flow (current US$) in Poland in 1997 to that in 1999?
Give a very brief answer. 0.56. What is the ratio of the Aid flow (current US$) of South Asia in 1997 to that in 2000?
Ensure brevity in your answer.  0.21. What is the ratio of the Aid flow (current US$) of China in 1997 to that in 2000?
Your response must be concise. 0.96. What is the ratio of the Aid flow (current US$) in Poland in 1997 to that in 2000?
Give a very brief answer. 0.15. What is the ratio of the Aid flow (current US$) of South Asia in 1997 to that in 2001?
Your answer should be very brief. 0.22. What is the ratio of the Aid flow (current US$) of China in 1997 to that in 2001?
Provide a short and direct response. 0.87. What is the ratio of the Aid flow (current US$) of Poland in 1997 to that in 2001?
Ensure brevity in your answer.  0.06. What is the ratio of the Aid flow (current US$) in South Asia in 1997 to that in 2002?
Make the answer very short. 0.2. What is the ratio of the Aid flow (current US$) in China in 1997 to that in 2002?
Offer a terse response. 0.53. What is the ratio of the Aid flow (current US$) in Georgia in 1997 to that in 2002?
Offer a terse response. 1. What is the ratio of the Aid flow (current US$) of Poland in 1997 to that in 2002?
Offer a very short reply. 0.33. What is the ratio of the Aid flow (current US$) of South Asia in 1997 to that in 2003?
Keep it short and to the point. 0.08. What is the ratio of the Aid flow (current US$) in China in 1997 to that in 2003?
Your response must be concise. 0.85. What is the ratio of the Aid flow (current US$) of Georgia in 1997 to that in 2003?
Offer a very short reply. 4. What is the ratio of the Aid flow (current US$) of Poland in 1997 to that in 2003?
Offer a terse response. 0.07. What is the ratio of the Aid flow (current US$) in South Asia in 1997 to that in 2004?
Your answer should be very brief. 0.08. What is the ratio of the Aid flow (current US$) of China in 1997 to that in 2004?
Provide a succinct answer. 0.55. What is the ratio of the Aid flow (current US$) in Poland in 1997 to that in 2004?
Keep it short and to the point. 0.38. What is the ratio of the Aid flow (current US$) in South Asia in 1999 to that in 2000?
Your response must be concise. 1.5. What is the ratio of the Aid flow (current US$) of China in 1999 to that in 2000?
Give a very brief answer. 1.59. What is the ratio of the Aid flow (current US$) in Poland in 1999 to that in 2000?
Ensure brevity in your answer.  0.26. What is the ratio of the Aid flow (current US$) of South Asia in 1999 to that in 2001?
Your response must be concise. 1.6. What is the ratio of the Aid flow (current US$) of China in 1999 to that in 2001?
Offer a very short reply. 1.43. What is the ratio of the Aid flow (current US$) of South Asia in 1999 to that in 2002?
Your answer should be compact. 1.4. What is the ratio of the Aid flow (current US$) of China in 1999 to that in 2002?
Offer a terse response. 0.87. What is the ratio of the Aid flow (current US$) in Poland in 1999 to that in 2002?
Make the answer very short. 0.6. What is the ratio of the Aid flow (current US$) of South Asia in 1999 to that in 2003?
Provide a succinct answer. 0.56. What is the ratio of the Aid flow (current US$) in China in 1999 to that in 2003?
Your answer should be compact. 1.41. What is the ratio of the Aid flow (current US$) in Poland in 1999 to that in 2003?
Your answer should be compact. 0.12. What is the ratio of the Aid flow (current US$) of South Asia in 1999 to that in 2004?
Give a very brief answer. 0.54. What is the ratio of the Aid flow (current US$) in China in 1999 to that in 2004?
Ensure brevity in your answer.  0.92. What is the ratio of the Aid flow (current US$) in Poland in 1999 to that in 2004?
Your answer should be compact. 0.69. What is the ratio of the Aid flow (current US$) in South Asia in 2000 to that in 2001?
Keep it short and to the point. 1.07. What is the ratio of the Aid flow (current US$) of China in 2000 to that in 2001?
Make the answer very short. 0.9. What is the ratio of the Aid flow (current US$) in Georgia in 2000 to that in 2001?
Make the answer very short. 3. What is the ratio of the Aid flow (current US$) in Poland in 2000 to that in 2001?
Offer a terse response. 0.42. What is the ratio of the Aid flow (current US$) of South Asia in 2000 to that in 2002?
Offer a very short reply. 0.94. What is the ratio of the Aid flow (current US$) in China in 2000 to that in 2002?
Provide a succinct answer. 0.55. What is the ratio of the Aid flow (current US$) in Poland in 2000 to that in 2002?
Ensure brevity in your answer.  2.27. What is the ratio of the Aid flow (current US$) in South Asia in 2000 to that in 2003?
Your response must be concise. 0.38. What is the ratio of the Aid flow (current US$) of China in 2000 to that in 2003?
Offer a terse response. 0.89. What is the ratio of the Aid flow (current US$) of Georgia in 2000 to that in 2003?
Offer a very short reply. 3. What is the ratio of the Aid flow (current US$) of Poland in 2000 to that in 2003?
Give a very brief answer. 0.46. What is the ratio of the Aid flow (current US$) in South Asia in 2000 to that in 2004?
Offer a terse response. 0.36. What is the ratio of the Aid flow (current US$) of China in 2000 to that in 2004?
Keep it short and to the point. 0.58. What is the ratio of the Aid flow (current US$) in Georgia in 2000 to that in 2004?
Give a very brief answer. 0.75. What is the ratio of the Aid flow (current US$) of Poland in 2000 to that in 2004?
Your response must be concise. 2.62. What is the ratio of the Aid flow (current US$) of South Asia in 2001 to that in 2002?
Keep it short and to the point. 0.88. What is the ratio of the Aid flow (current US$) in China in 2001 to that in 2002?
Your response must be concise. 0.61. What is the ratio of the Aid flow (current US$) in Georgia in 2001 to that in 2002?
Offer a very short reply. 0.25. What is the ratio of the Aid flow (current US$) in South Asia in 2001 to that in 2003?
Provide a short and direct response. 0.35. What is the ratio of the Aid flow (current US$) in China in 2001 to that in 2003?
Keep it short and to the point. 0.99. What is the ratio of the Aid flow (current US$) in Georgia in 2001 to that in 2003?
Provide a succinct answer. 1. What is the ratio of the Aid flow (current US$) of Poland in 2001 to that in 2003?
Keep it short and to the point. 1.09. What is the ratio of the Aid flow (current US$) of South Asia in 2001 to that in 2004?
Offer a terse response. 0.34. What is the ratio of the Aid flow (current US$) in China in 2001 to that in 2004?
Ensure brevity in your answer.  0.64. What is the ratio of the Aid flow (current US$) in Poland in 2001 to that in 2004?
Keep it short and to the point. 6.23. What is the ratio of the Aid flow (current US$) in South Asia in 2002 to that in 2003?
Your answer should be compact. 0.4. What is the ratio of the Aid flow (current US$) in China in 2002 to that in 2003?
Your answer should be very brief. 1.62. What is the ratio of the Aid flow (current US$) of Poland in 2002 to that in 2003?
Offer a very short reply. 0.2. What is the ratio of the Aid flow (current US$) of South Asia in 2002 to that in 2004?
Your answer should be compact. 0.39. What is the ratio of the Aid flow (current US$) of China in 2002 to that in 2004?
Your answer should be very brief. 1.05. What is the ratio of the Aid flow (current US$) of Poland in 2002 to that in 2004?
Your answer should be very brief. 1.15. What is the ratio of the Aid flow (current US$) in South Asia in 2003 to that in 2004?
Your answer should be very brief. 0.96. What is the ratio of the Aid flow (current US$) in China in 2003 to that in 2004?
Make the answer very short. 0.65. What is the ratio of the Aid flow (current US$) in Poland in 2003 to that in 2004?
Offer a very short reply. 5.69. What is the difference between the highest and the second highest Aid flow (current US$) in South Asia?
Offer a terse response. 1.90e+06. What is the difference between the highest and the second highest Aid flow (current US$) in China?
Provide a short and direct response. 1.42e+07. What is the difference between the highest and the second highest Aid flow (current US$) of Georgia?
Provide a succinct answer. 10000. What is the difference between the highest and the lowest Aid flow (current US$) of South Asia?
Offer a very short reply. 5.01e+07. What is the difference between the highest and the lowest Aid flow (current US$) of China?
Offer a very short reply. 2.67e+07. What is the difference between the highest and the lowest Aid flow (current US$) of Poland?
Ensure brevity in your answer.  7.60e+05. 